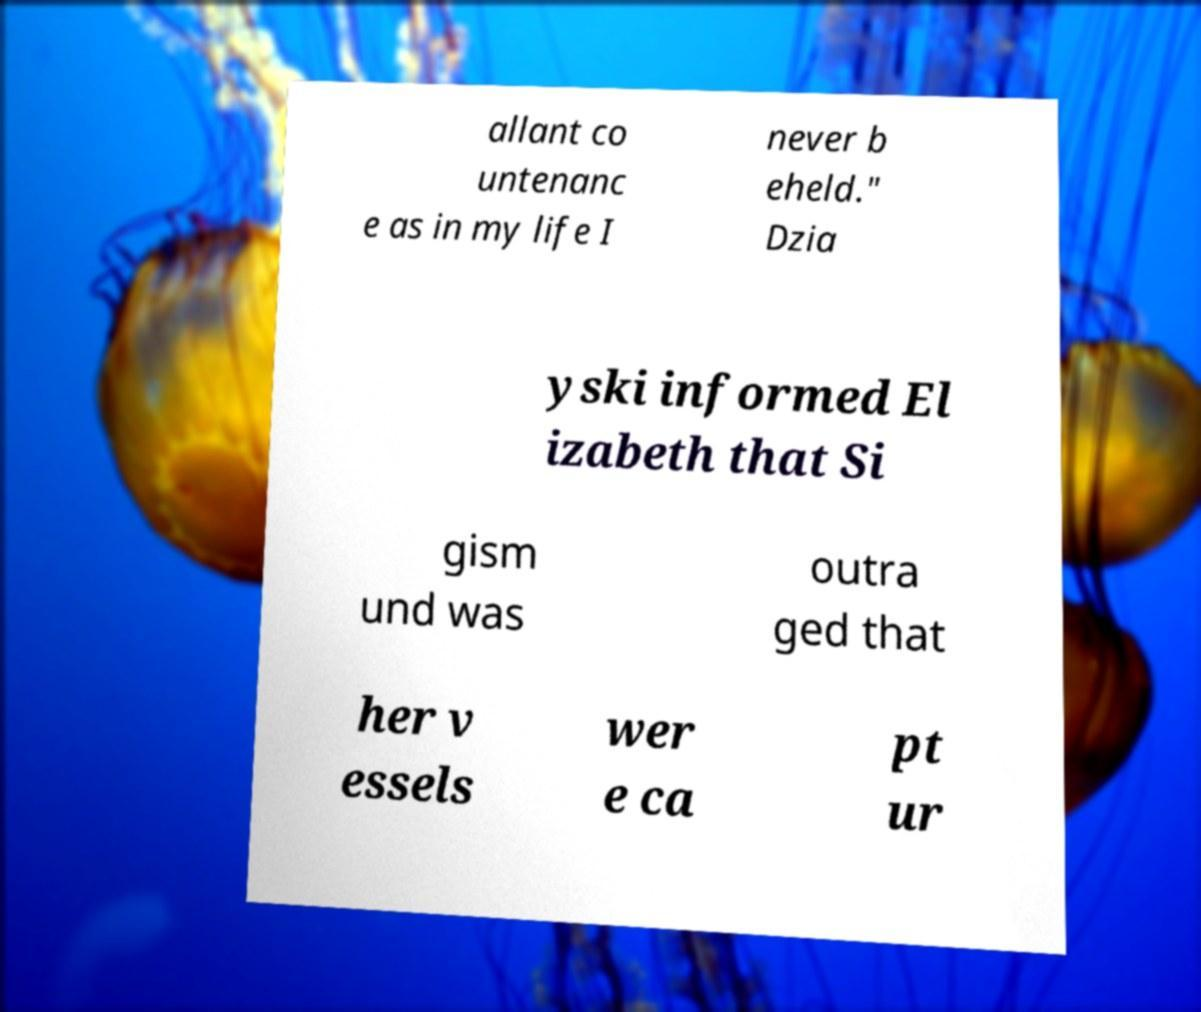Could you extract and type out the text from this image? allant co untenanc e as in my life I never b eheld." Dzia yski informed El izabeth that Si gism und was outra ged that her v essels wer e ca pt ur 